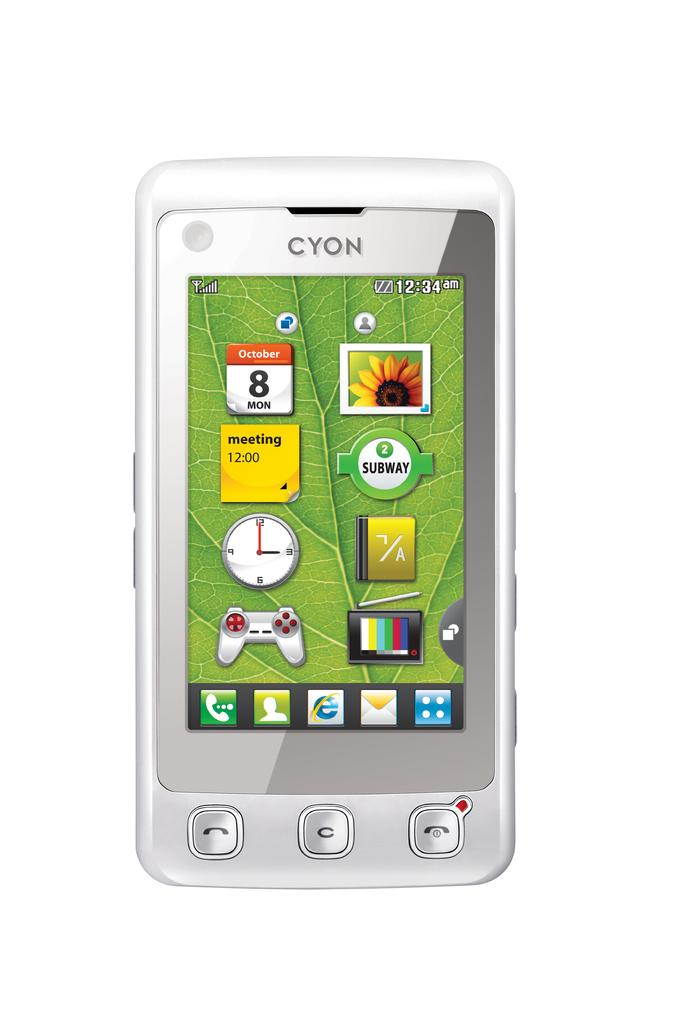<image>
Describe the image concisely. A cell phone with the brand Cyon showing apps. 